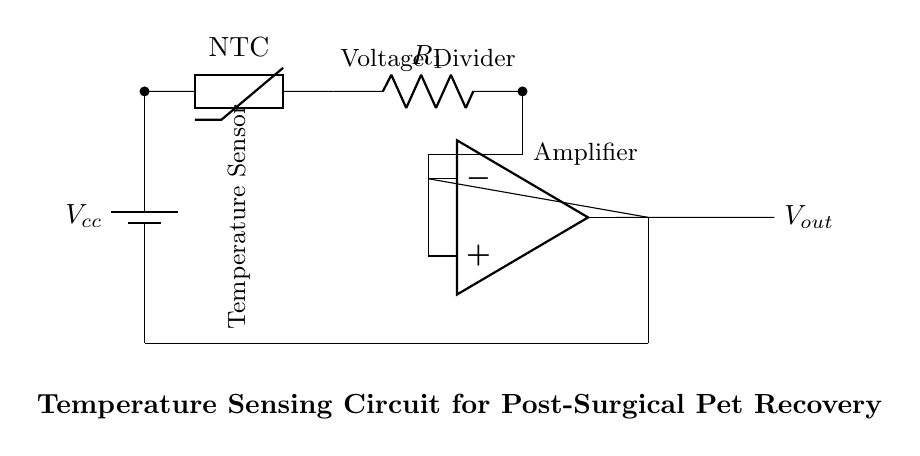What type of temperature sensor is used in this circuit? The circuit diagram specifies an NTC thermistor, which is indicated next to the symbol for the temperature sensor. NTC stands for negative temperature coefficient, meaning its resistance decreases as temperature increases.
Answer: NTC thermistor What is the purpose of the resistor in this circuit? The resistor acts as part of a voltage divider with the thermistor. Together, these components create a network that translates temperature changes into a change in voltage that can be measured.
Answer: Voltage divider What is the output of the circuit labeled as? The output signal of the circuit is labeled as Vout, which indicates the voltage that reflects temperature readings based on the thermistor's resistance.
Answer: Vout What type of amplifier is used in this circuit? The diagram shows a standard operational amplifier symbol. This type of amplifier is commonly used to increase the voltage signal from the thermistor and resistor circuit.
Answer: Operational amplifier Why is an op-amp used instead of a simple resistor connection for the output? Using an operational amplifier allows for amplification of the voltage signal generated by the thermistor and resistor, providing a stronger output for more accurate readings. Additionally, it improves the circuit’s sensitivity and overall performance when measuring slight temperature variations.
Answer: Amplification and sensitivity 